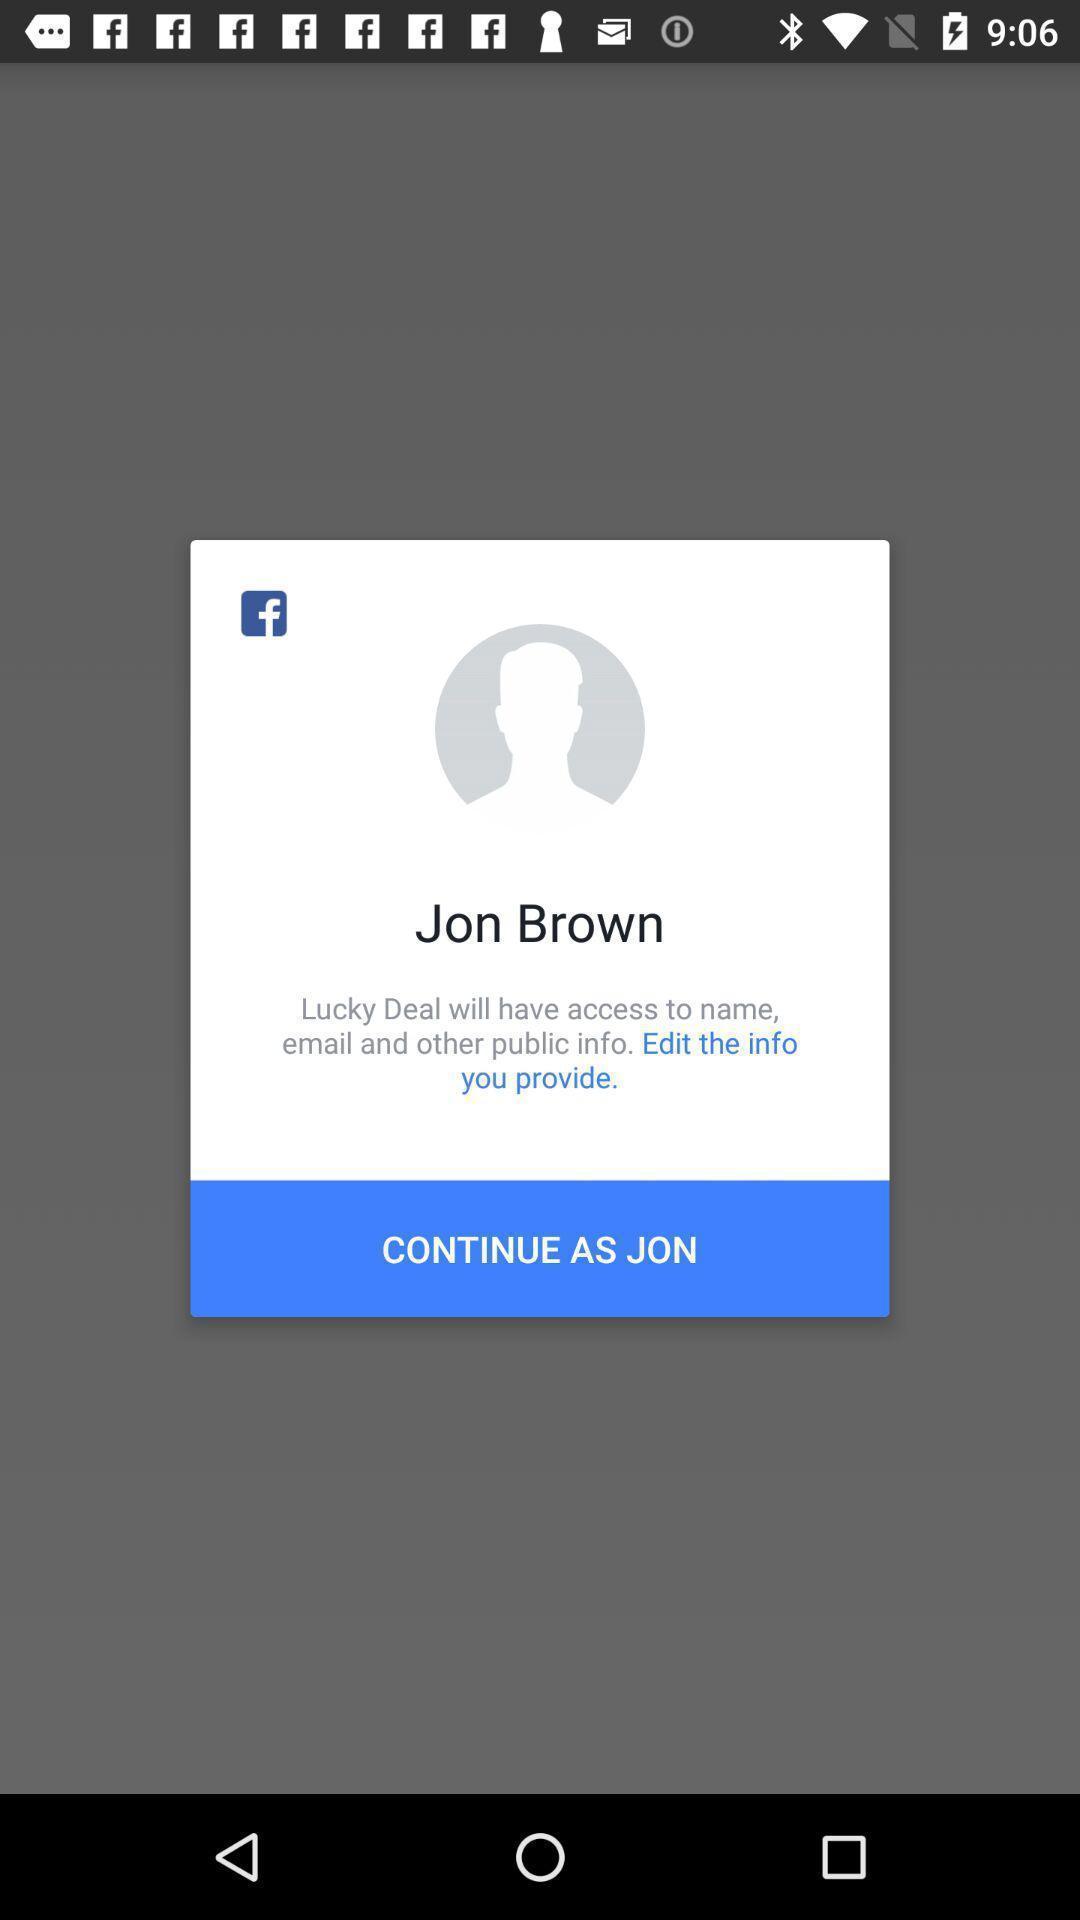Please provide a description for this image. Pop-up showing continue option by using a social media app. 